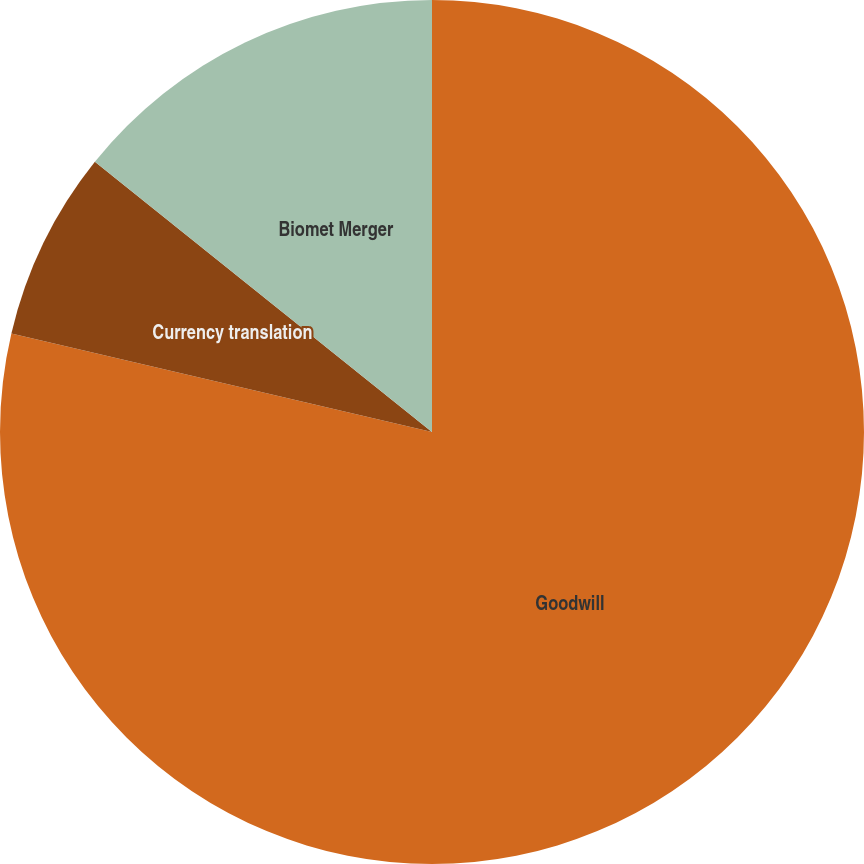Convert chart. <chart><loc_0><loc_0><loc_500><loc_500><pie_chart><fcel>Goodwill<fcel>Currency translation<fcel>Biomet Merger<nl><fcel>78.67%<fcel>7.09%<fcel>14.25%<nl></chart> 